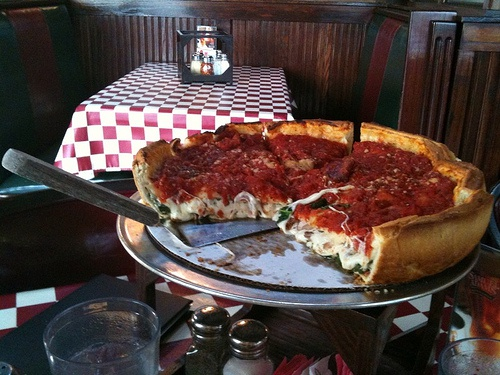Describe the objects in this image and their specific colors. I can see dining table in black, maroon, gray, and darkgray tones, pizza in black, maroon, and brown tones, chair in black, gray, and maroon tones, dining table in black, lightgray, gray, and darkgray tones, and cup in black, gray, and darkblue tones in this image. 